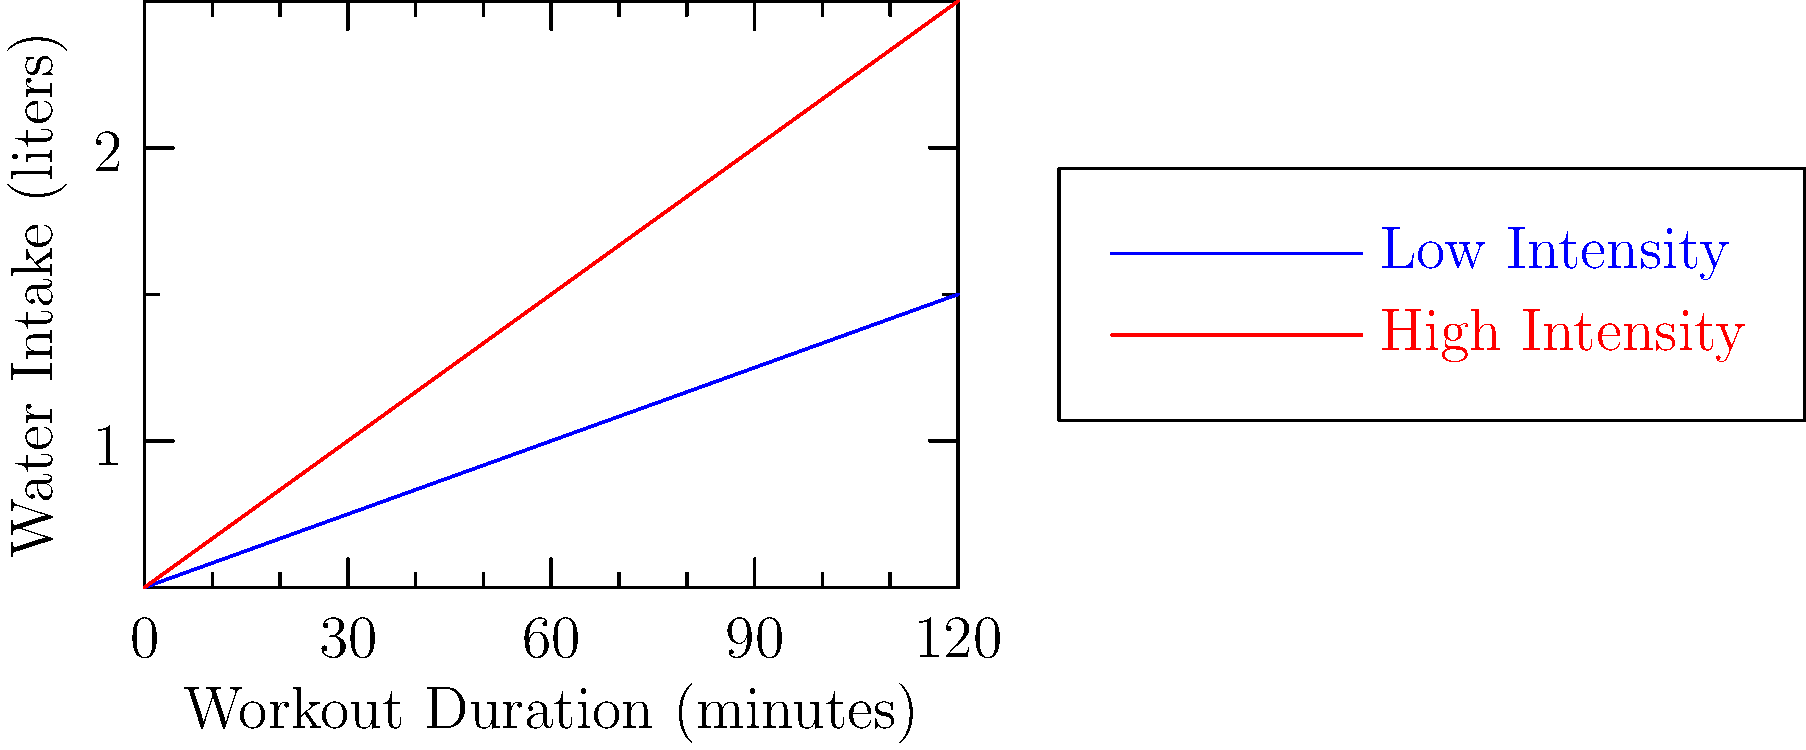Based on the graph, what is the difference in water intake between high-intensity and low-intensity workouts after 90 minutes of exercise? To find the difference in water intake between high-intensity and low-intensity workouts after 90 minutes:

1. Locate the 90-minute mark on the x-axis.
2. Find the corresponding water intake for high-intensity (red line):
   At 90 minutes, high-intensity ≈ 2.0 liters
3. Find the corresponding water intake for low-intensity (blue line):
   At 90 minutes, low-intensity ≈ 1.25 liters
4. Calculate the difference:
   $\text{Difference} = \text{High-intensity} - \text{Low-intensity}$
   $\text{Difference} = 2.0 - 1.25 = 0.75 \text{ liters}$

Therefore, the difference in water intake between high-intensity and low-intensity workouts after 90 minutes is approximately 0.75 liters.
Answer: 0.75 liters 